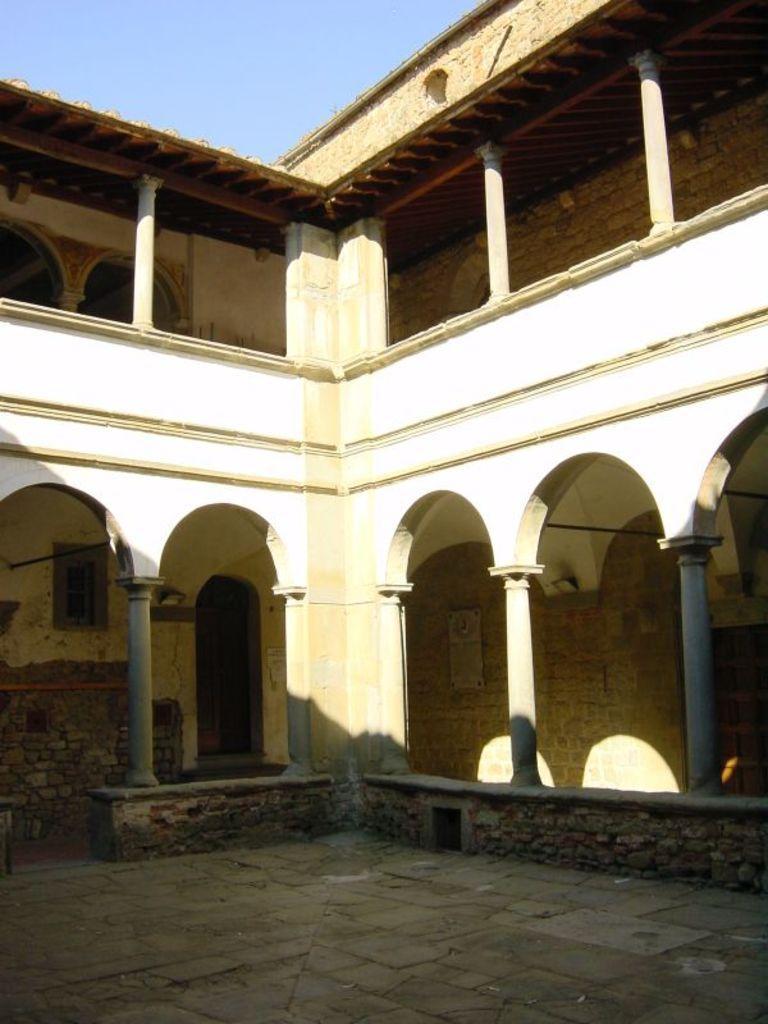Can you describe this image briefly? In the image we can see there is a building and there are pillars. The wall of the building is made up of stone bricks and there are stone tiles on the ground. There is a clear sky. 